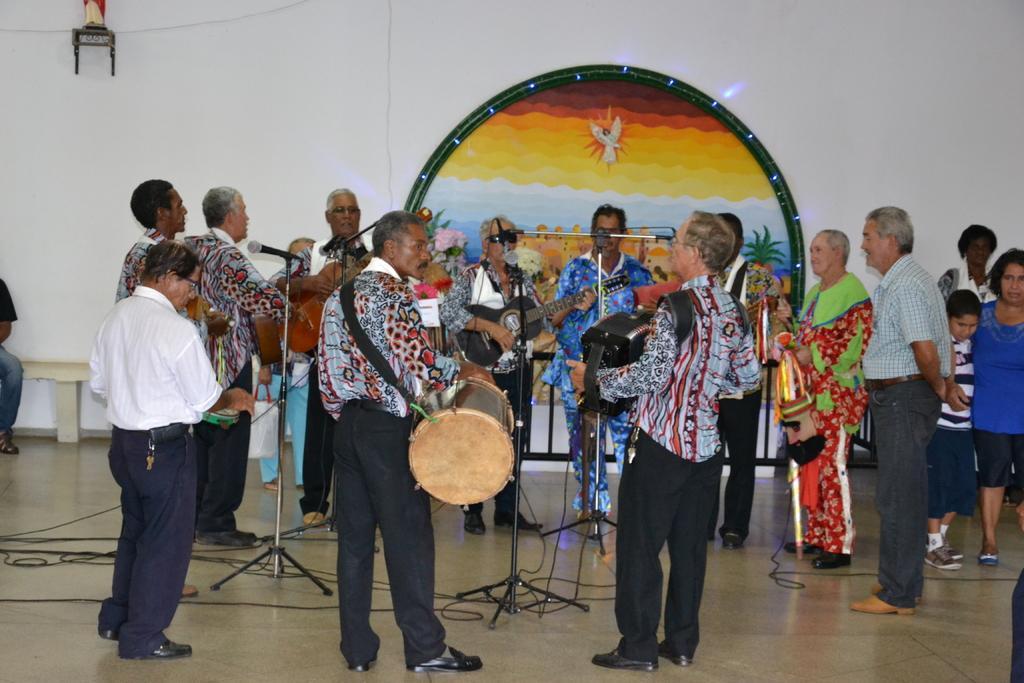How would you summarize this image in a sentence or two? There are some people in this group playing a different musical instruments in front of a microphone and a stand. Some of them was standing and watching. In the background there is a wall and a painting here. 